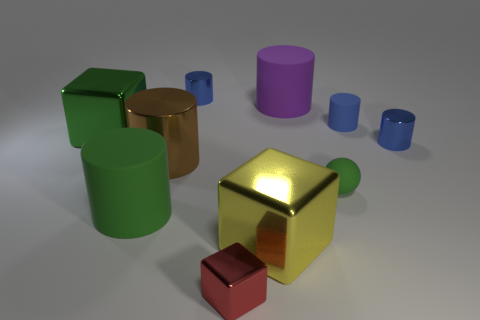How many blue cylinders must be subtracted to get 1 blue cylinders? 2 Subtract all green rubber cylinders. How many cylinders are left? 5 Subtract all green blocks. How many blocks are left? 2 Subtract 4 cylinders. How many cylinders are left? 2 Subtract all balls. How many objects are left? 9 Subtract all gray balls. How many green cylinders are left? 1 Subtract all tiny cyan cylinders. Subtract all brown metal cylinders. How many objects are left? 9 Add 2 large brown objects. How many large brown objects are left? 3 Add 1 purple cylinders. How many purple cylinders exist? 2 Subtract 1 green cubes. How many objects are left? 9 